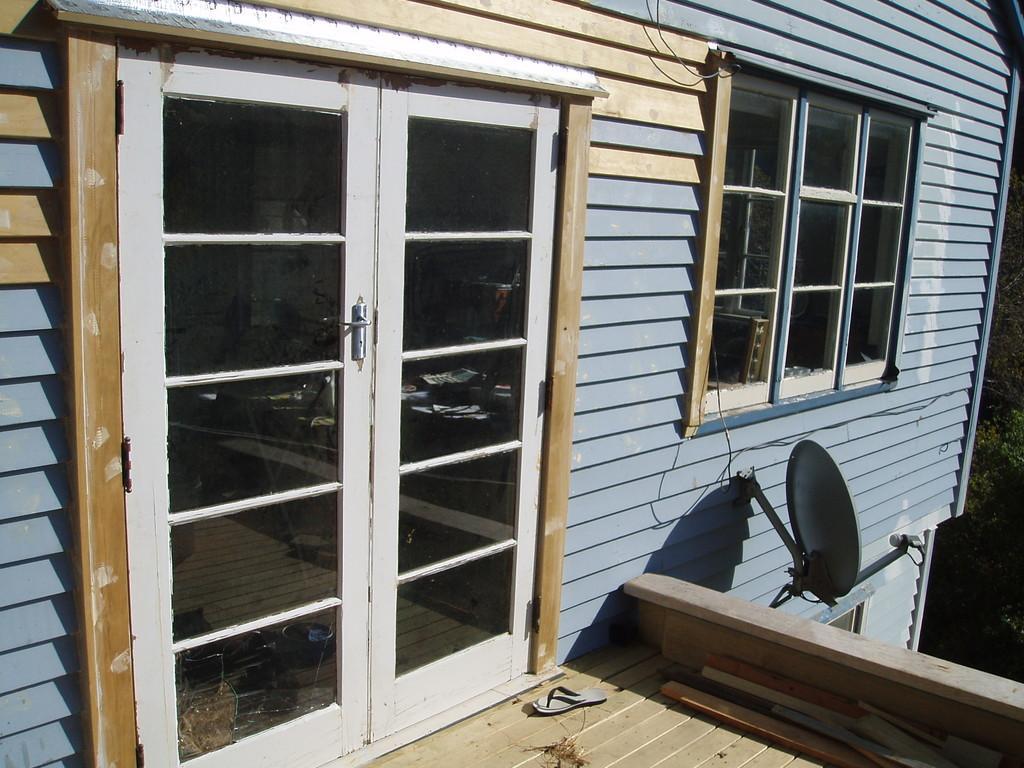How would you summarize this image in a sentence or two? In this image I can see a building and on the right side I can see a tree. In the front of this image I can see few doors, a slipper and an antenna on the building. 